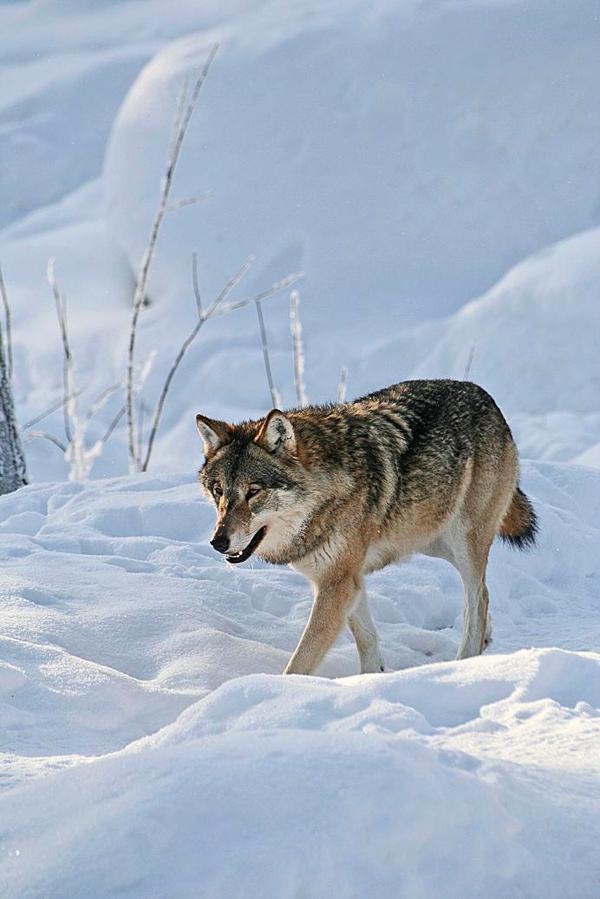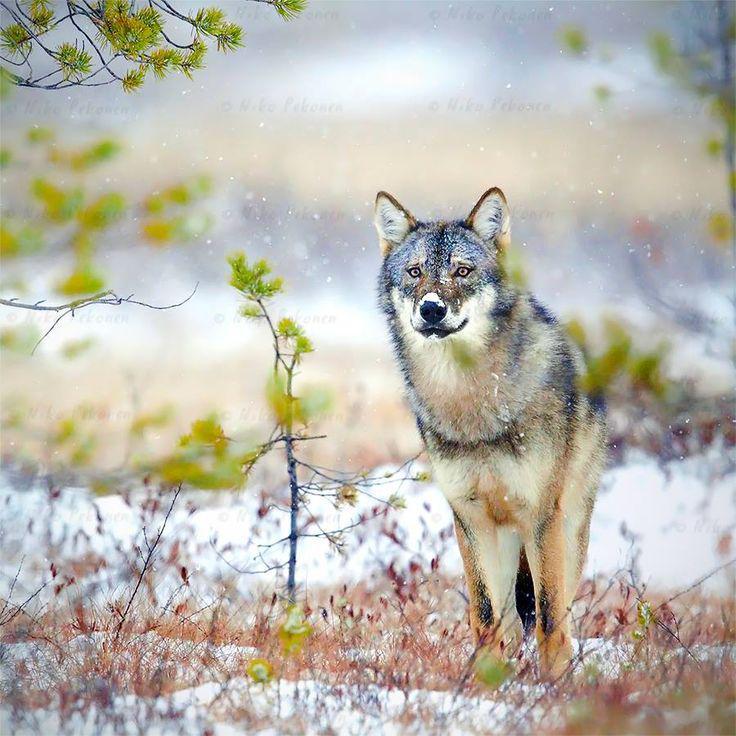The first image is the image on the left, the second image is the image on the right. Examine the images to the left and right. Is the description "in the left image there is a wold walking on snow covered ground with twigs sticking up through the snow" accurate? Answer yes or no. Yes. 